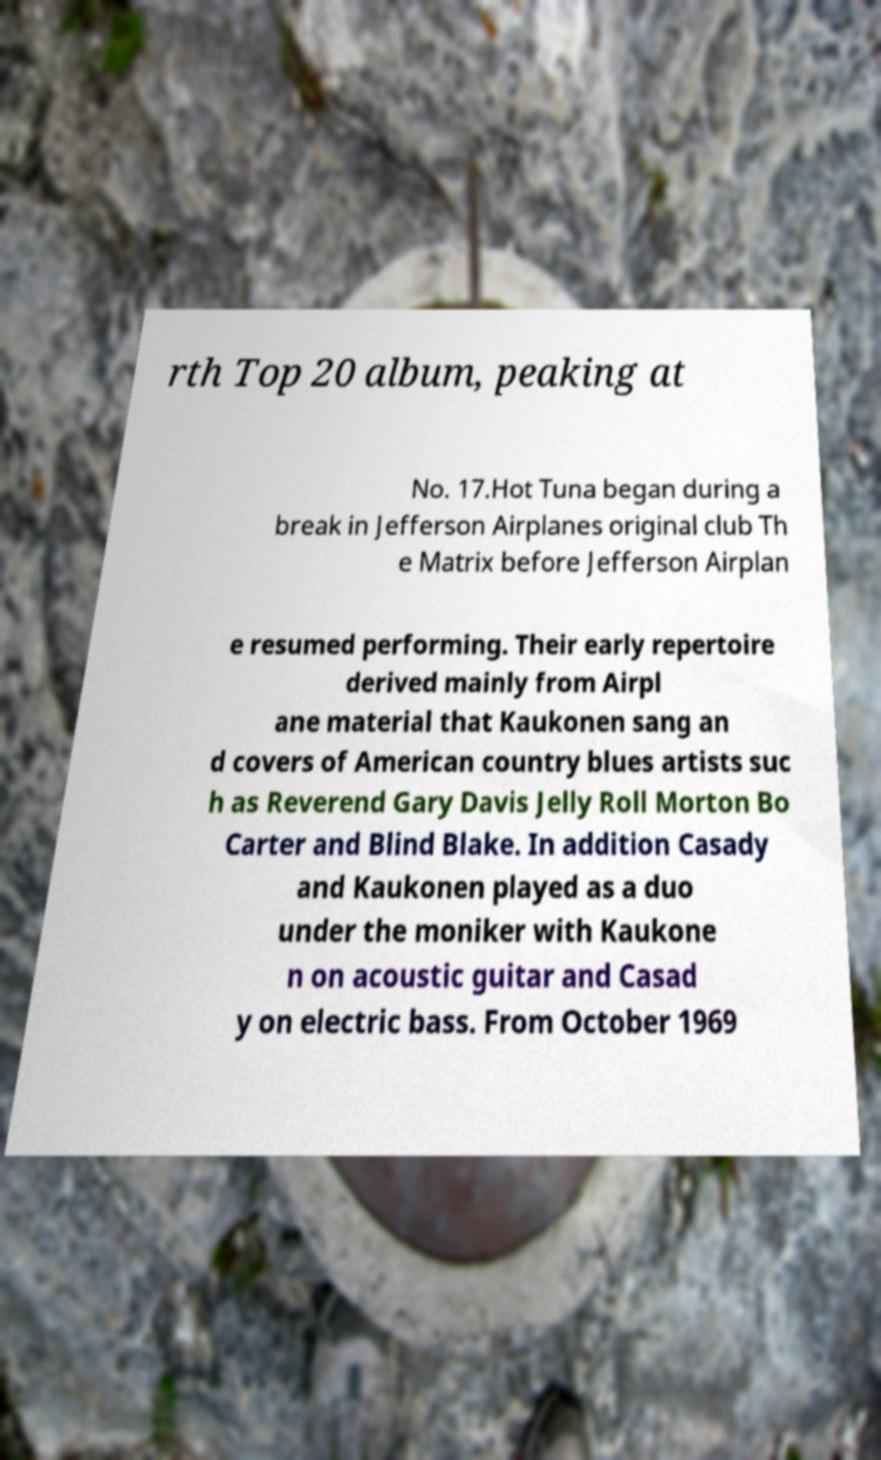There's text embedded in this image that I need extracted. Can you transcribe it verbatim? rth Top 20 album, peaking at No. 17.Hot Tuna began during a break in Jefferson Airplanes original club Th e Matrix before Jefferson Airplan e resumed performing. Their early repertoire derived mainly from Airpl ane material that Kaukonen sang an d covers of American country blues artists suc h as Reverend Gary Davis Jelly Roll Morton Bo Carter and Blind Blake. In addition Casady and Kaukonen played as a duo under the moniker with Kaukone n on acoustic guitar and Casad y on electric bass. From October 1969 